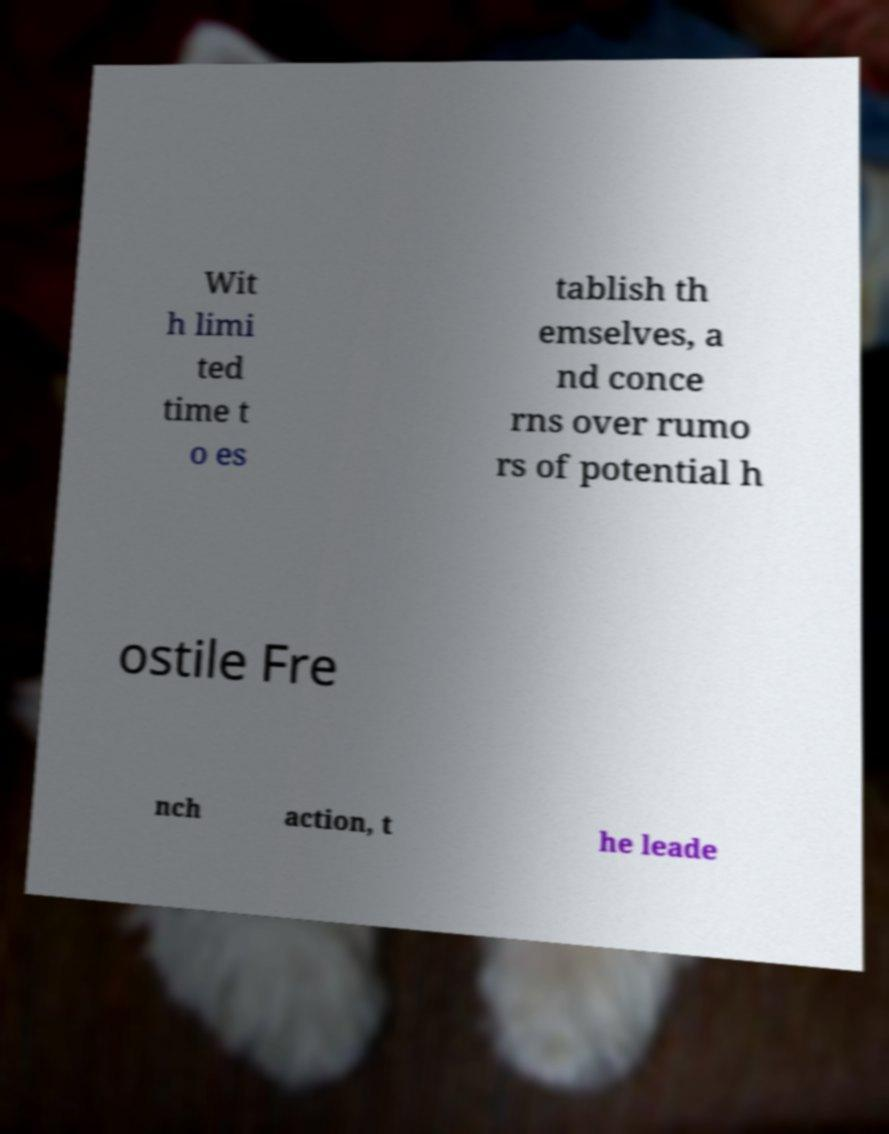I need the written content from this picture converted into text. Can you do that? Wit h limi ted time t o es tablish th emselves, a nd conce rns over rumo rs of potential h ostile Fre nch action, t he leade 